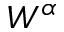Convert formula to latex. <formula><loc_0><loc_0><loc_500><loc_500>W ^ { \alpha }</formula> 